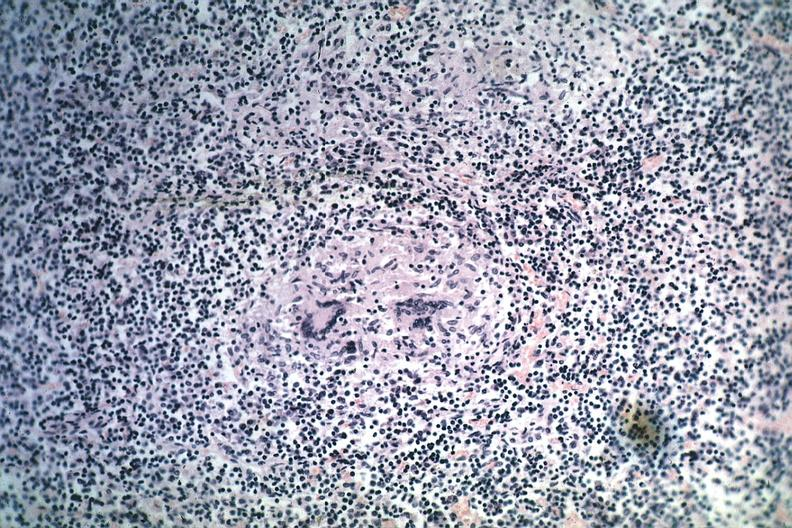s krukenberg tumor present?
Answer the question using a single word or phrase. No 